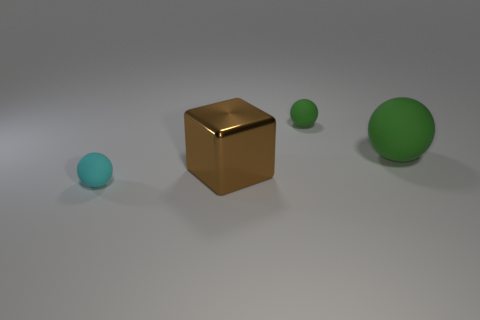There is a cyan matte thing; is its size the same as the green matte sphere on the left side of the big green sphere?
Offer a terse response. Yes. There is another small rubber thing that is the same shape as the cyan thing; what color is it?
Keep it short and to the point. Green. There is a rubber thing in front of the metal thing; is its size the same as the metallic object in front of the large green matte thing?
Your response must be concise. No. Is the tiny green rubber object the same shape as the metallic object?
Offer a very short reply. No. What number of things are either tiny balls behind the shiny object or rubber cylinders?
Provide a short and direct response. 1. Is there a cyan rubber object that has the same shape as the tiny green rubber thing?
Your answer should be very brief. Yes. Is the number of small green balls that are right of the large brown thing the same as the number of green rubber balls?
Your response must be concise. No. How many other cyan objects have the same size as the cyan thing?
Your response must be concise. 0. What number of small rubber balls are to the right of the big shiny object?
Give a very brief answer. 1. What material is the big cube left of the green ball that is behind the big rubber sphere?
Make the answer very short. Metal. 